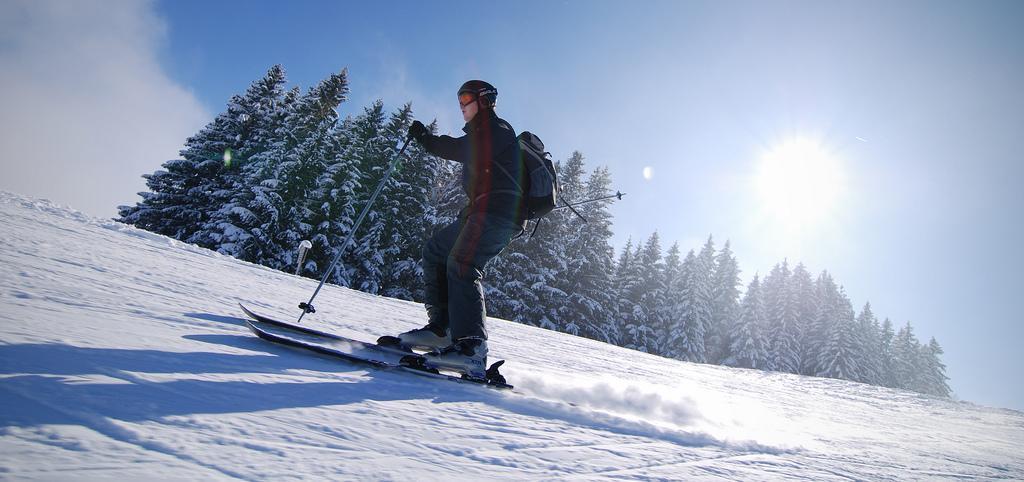How many palm trees are pictured?
Give a very brief answer. 1. How many skis are used?
Give a very brief answer. 2. How many skis is the man wearing?
Give a very brief answer. 2. How many skiers are there?
Give a very brief answer. 1. How many ski poles is the person holding?
Give a very brief answer. 1. 